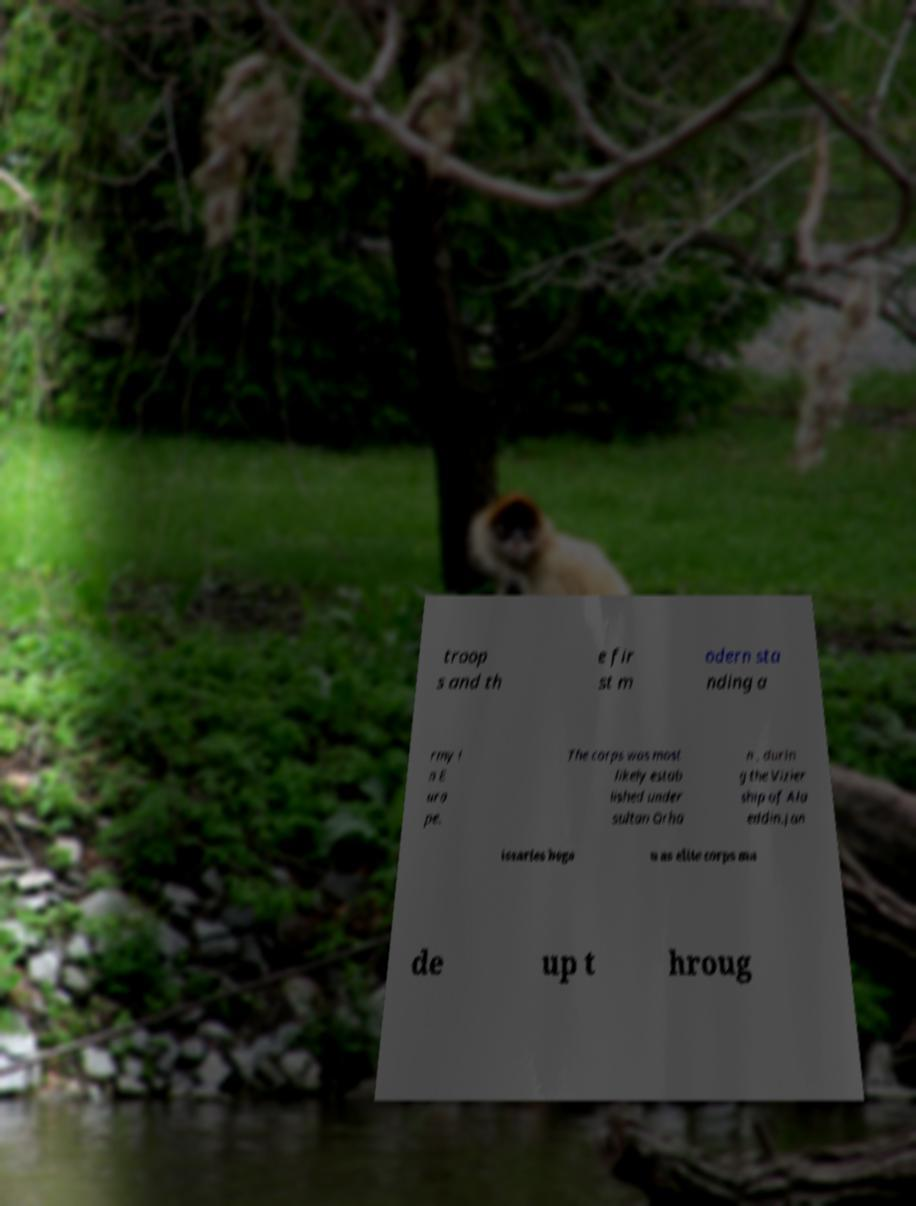Please identify and transcribe the text found in this image. troop s and th e fir st m odern sta nding a rmy i n E uro pe. The corps was most likely estab lished under sultan Orha n , durin g the Vizier ship of Ala eddin.Jan issaries bega n as elite corps ma de up t hroug 